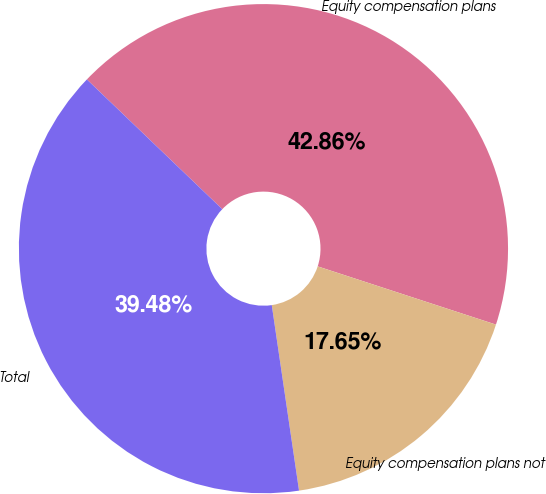Convert chart. <chart><loc_0><loc_0><loc_500><loc_500><pie_chart><fcel>Equity compensation plans<fcel>Equity compensation plans not<fcel>Total<nl><fcel>42.86%<fcel>17.65%<fcel>39.48%<nl></chart> 